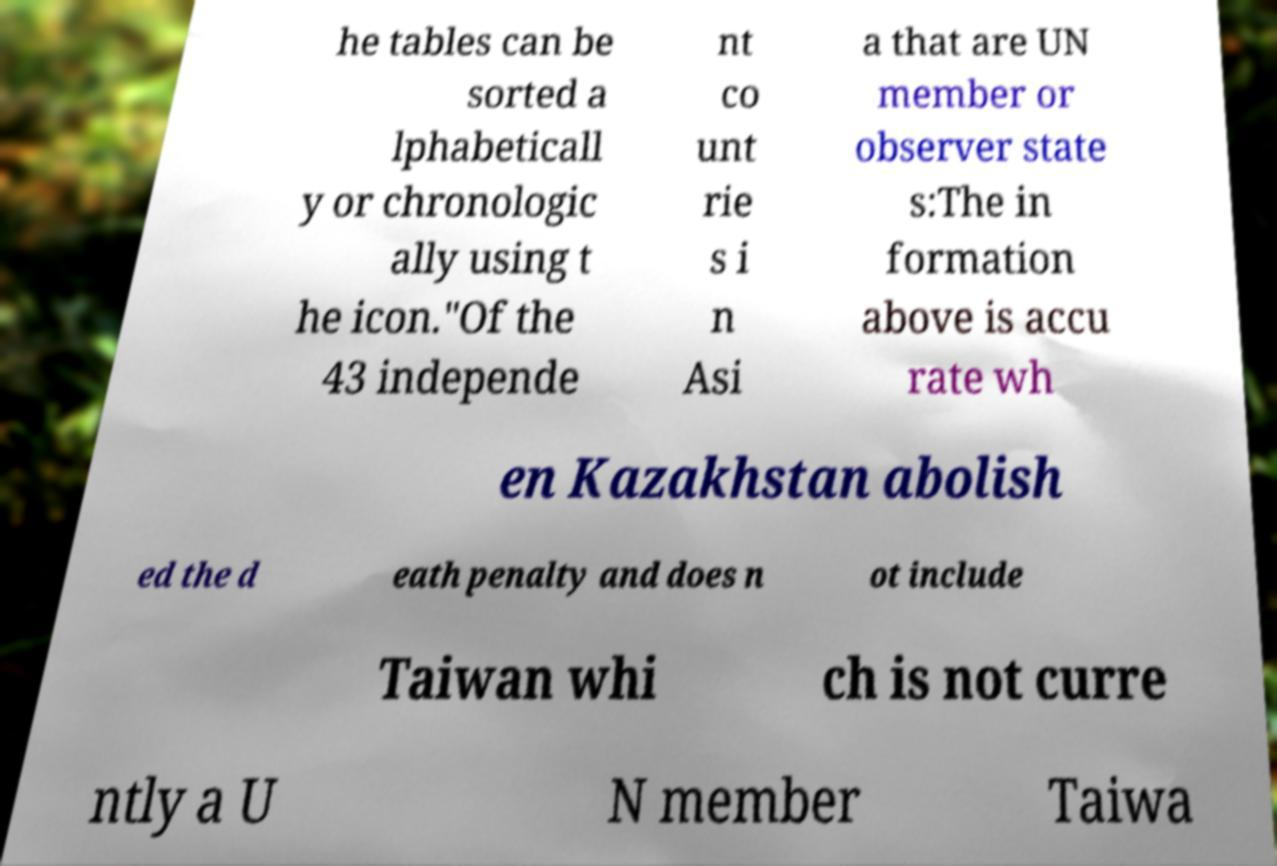For documentation purposes, I need the text within this image transcribed. Could you provide that? he tables can be sorted a lphabeticall y or chronologic ally using t he icon."Of the 43 independe nt co unt rie s i n Asi a that are UN member or observer state s:The in formation above is accu rate wh en Kazakhstan abolish ed the d eath penalty and does n ot include Taiwan whi ch is not curre ntly a U N member Taiwa 